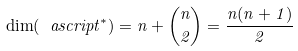Convert formula to latex. <formula><loc_0><loc_0><loc_500><loc_500>\dim ( \ a s c r i p t ^ { * } ) = n + \binom { n } { 2 } = \frac { n ( n + 1 ) } { 2 }</formula> 